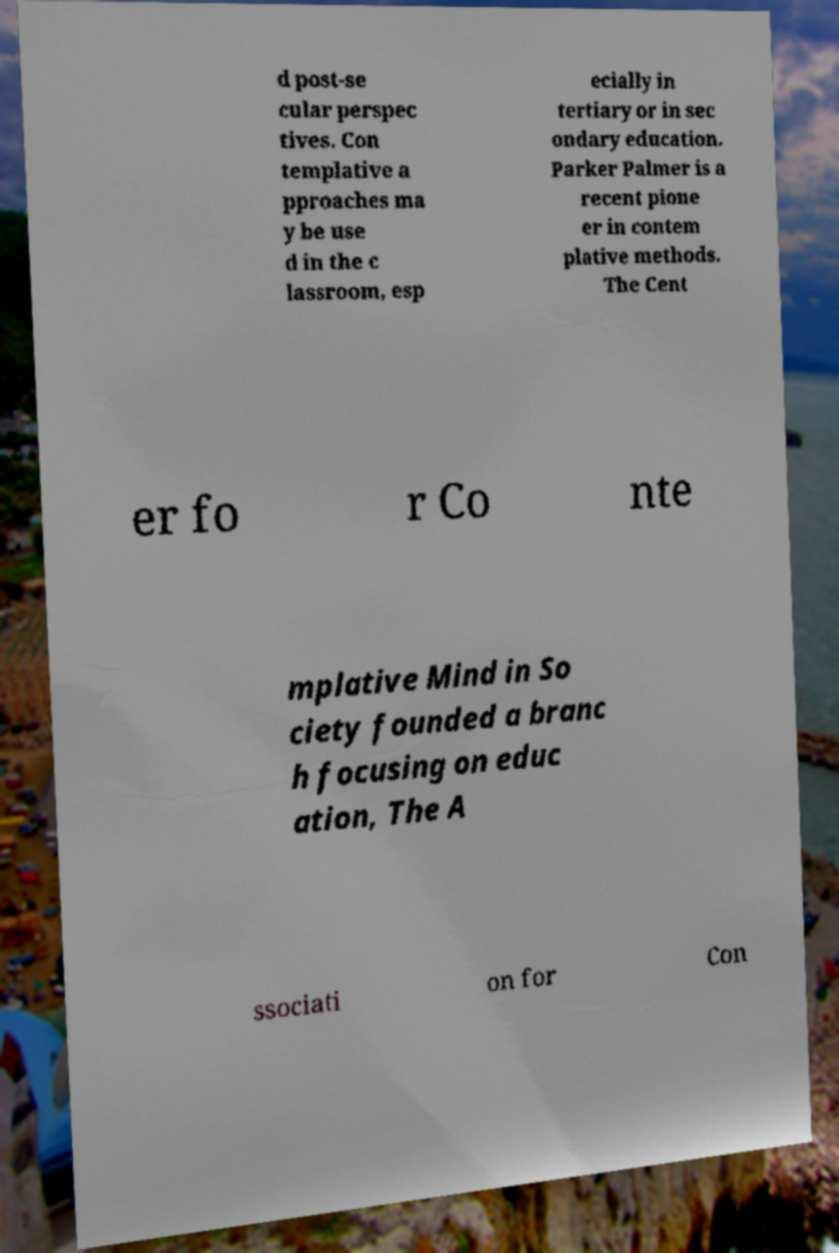Could you extract and type out the text from this image? d post-se cular perspec tives. Con templative a pproaches ma y be use d in the c lassroom, esp ecially in tertiary or in sec ondary education. Parker Palmer is a recent pione er in contem plative methods. The Cent er fo r Co nte mplative Mind in So ciety founded a branc h focusing on educ ation, The A ssociati on for Con 